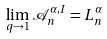<formula> <loc_0><loc_0><loc_500><loc_500>\lim _ { q \rightarrow 1 } { \mathcal { A } } _ { n } ^ { \alpha , I } = L _ { n } ^ { \alpha }</formula> 